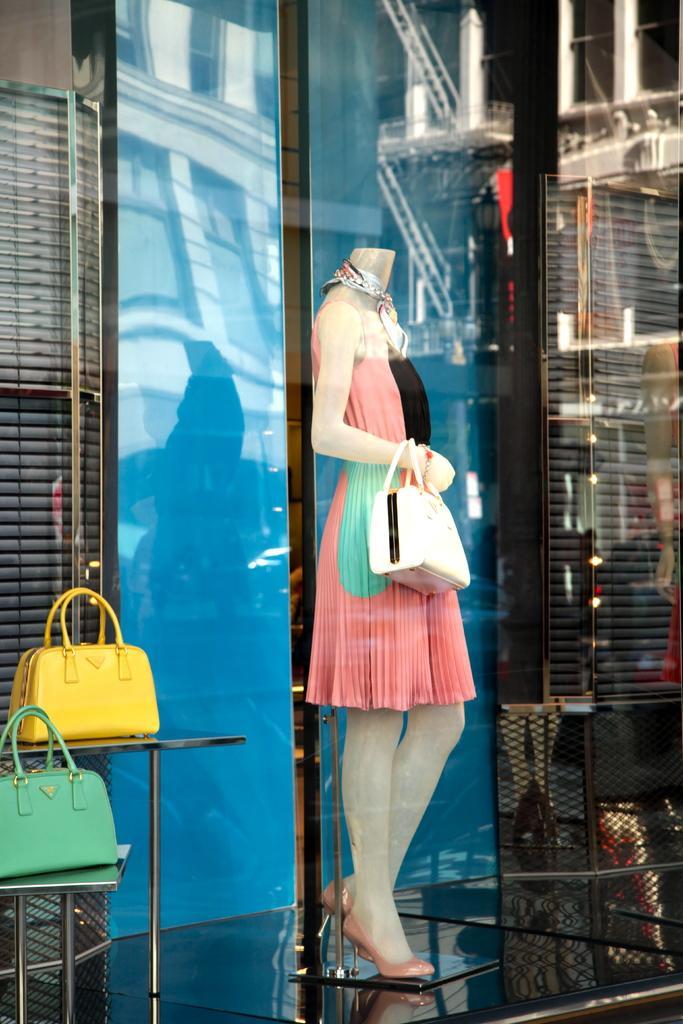How would you summarize this image in a sentence or two? In this picture we can see a mannequin holding bag and beside to her we can see green and yellow color bags placed on a rack for showcase. 